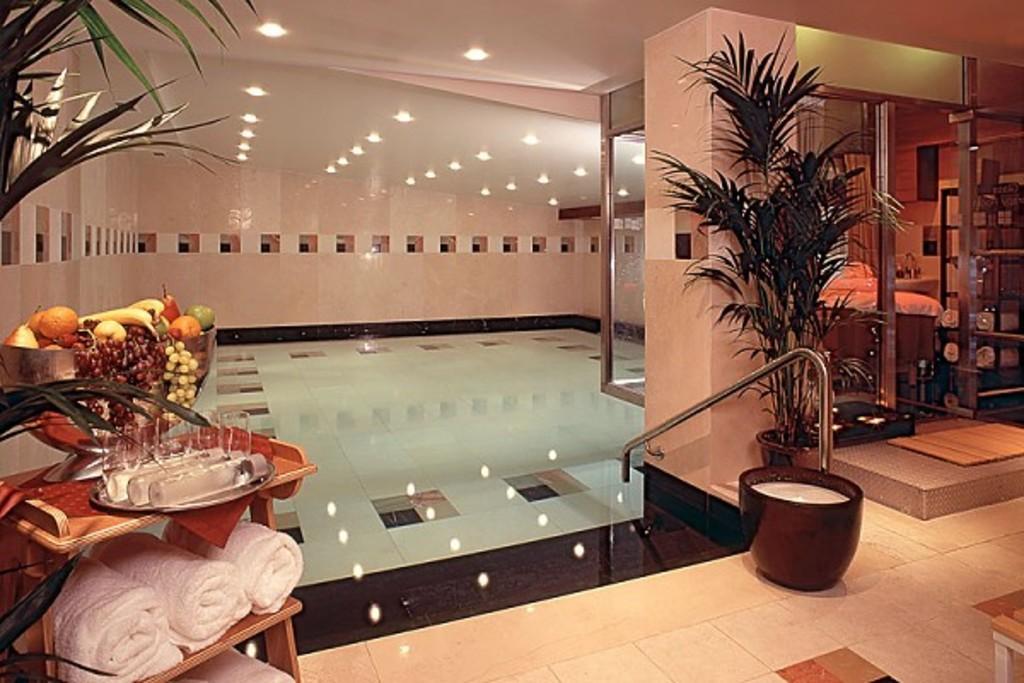Could you give a brief overview of what you see in this image? In this picture we can see some fruits in a bowl. There are few glasses and bottles on a wooden table. Few towels are seen in a wooden table on the left side. We can see a flower pot on the path. There are some towels in the shelves on the right side. Some lights are visible on top. There is a stand on the path. 